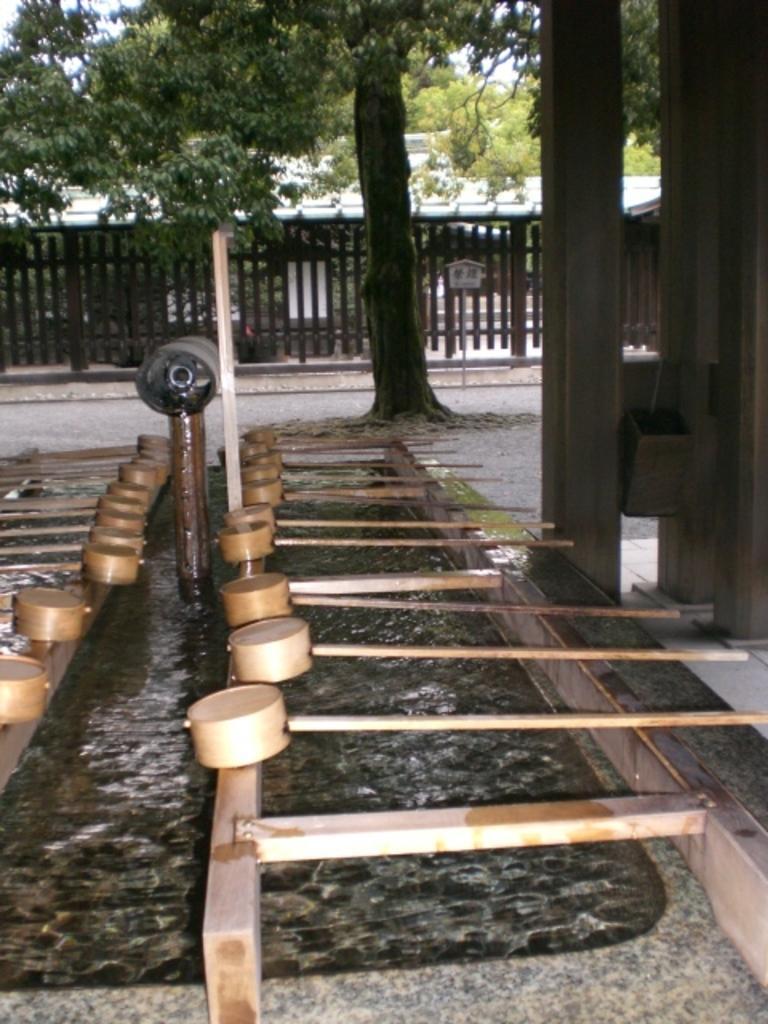Please provide a concise description of this image. In this image I can see fence, trees, wooden objects and some other objects on the ground. 